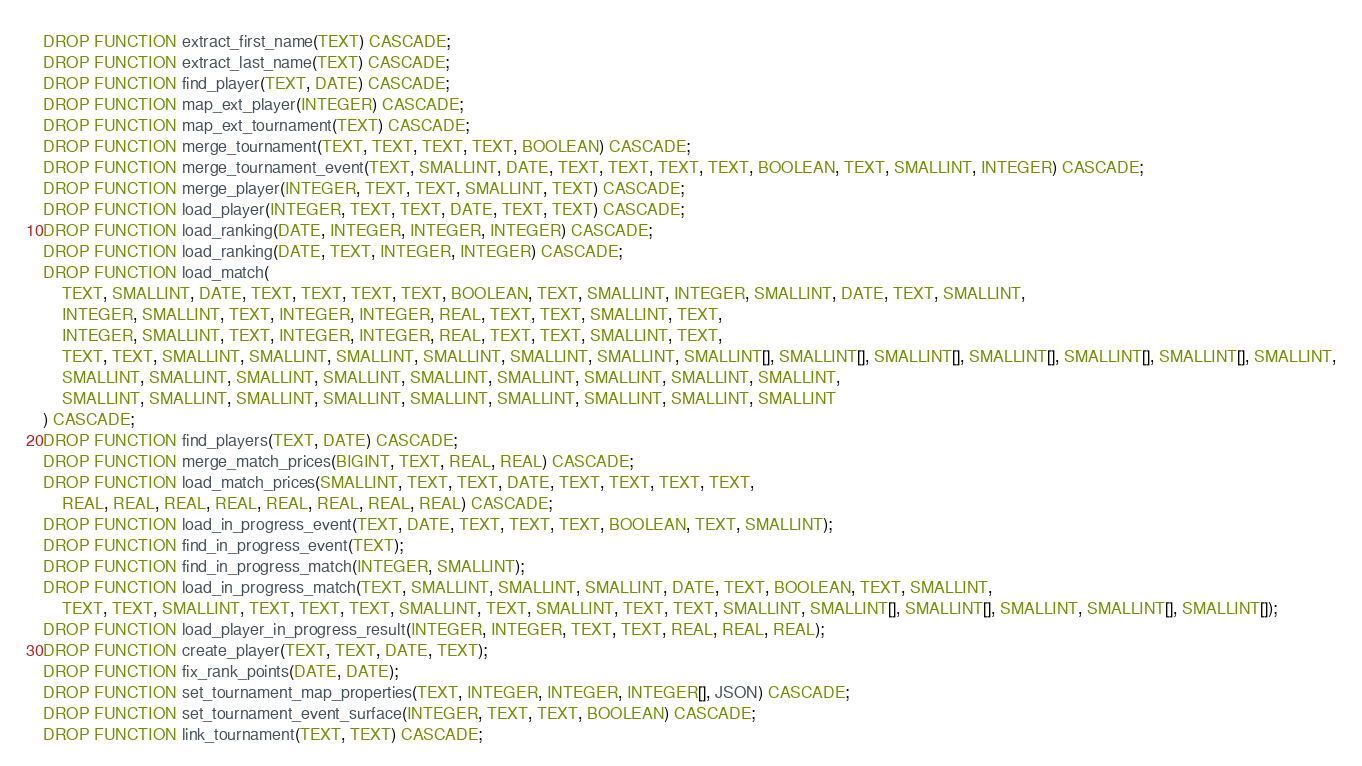<code> <loc_0><loc_0><loc_500><loc_500><_SQL_>DROP FUNCTION extract_first_name(TEXT) CASCADE;
DROP FUNCTION extract_last_name(TEXT) CASCADE;
DROP FUNCTION find_player(TEXT, DATE) CASCADE;
DROP FUNCTION map_ext_player(INTEGER) CASCADE;
DROP FUNCTION map_ext_tournament(TEXT) CASCADE;
DROP FUNCTION merge_tournament(TEXT, TEXT, TEXT, TEXT, BOOLEAN) CASCADE;
DROP FUNCTION merge_tournament_event(TEXT, SMALLINT, DATE, TEXT, TEXT, TEXT, TEXT, BOOLEAN, TEXT, SMALLINT, INTEGER) CASCADE;
DROP FUNCTION merge_player(INTEGER, TEXT, TEXT, SMALLINT, TEXT) CASCADE;
DROP FUNCTION load_player(INTEGER, TEXT, TEXT, DATE, TEXT, TEXT) CASCADE;
DROP FUNCTION load_ranking(DATE, INTEGER, INTEGER, INTEGER) CASCADE;
DROP FUNCTION load_ranking(DATE, TEXT, INTEGER, INTEGER) CASCADE;
DROP FUNCTION load_match(
	TEXT, SMALLINT, DATE, TEXT, TEXT, TEXT, TEXT, BOOLEAN, TEXT, SMALLINT, INTEGER, SMALLINT, DATE, TEXT, SMALLINT,
	INTEGER, SMALLINT, TEXT, INTEGER, INTEGER, REAL, TEXT, TEXT, SMALLINT, TEXT,
	INTEGER, SMALLINT, TEXT, INTEGER, INTEGER, REAL, TEXT, TEXT, SMALLINT, TEXT,
	TEXT, TEXT, SMALLINT, SMALLINT, SMALLINT, SMALLINT, SMALLINT, SMALLINT, SMALLINT[], SMALLINT[], SMALLINT[], SMALLINT[], SMALLINT[], SMALLINT[], SMALLINT,
	SMALLINT, SMALLINT, SMALLINT, SMALLINT, SMALLINT, SMALLINT, SMALLINT, SMALLINT, SMALLINT,
	SMALLINT, SMALLINT, SMALLINT, SMALLINT, SMALLINT, SMALLINT, SMALLINT, SMALLINT, SMALLINT
) CASCADE;
DROP FUNCTION find_players(TEXT, DATE) CASCADE;
DROP FUNCTION merge_match_prices(BIGINT, TEXT, REAL, REAL) CASCADE;
DROP FUNCTION load_match_prices(SMALLINT, TEXT, TEXT, DATE, TEXT, TEXT, TEXT, TEXT,
	REAL, REAL, REAL, REAL, REAL, REAL, REAL, REAL) CASCADE;
DROP FUNCTION load_in_progress_event(TEXT, DATE, TEXT, TEXT, TEXT, BOOLEAN, TEXT, SMALLINT);
DROP FUNCTION find_in_progress_event(TEXT);
DROP FUNCTION find_in_progress_match(INTEGER, SMALLINT);
DROP FUNCTION load_in_progress_match(TEXT, SMALLINT, SMALLINT, SMALLINT, DATE, TEXT, BOOLEAN, TEXT, SMALLINT,
	TEXT, TEXT, SMALLINT, TEXT, TEXT, TEXT, SMALLINT, TEXT, SMALLINT, TEXT, TEXT, SMALLINT, SMALLINT[], SMALLINT[], SMALLINT, SMALLINT[], SMALLINT[]);
DROP FUNCTION load_player_in_progress_result(INTEGER, INTEGER, TEXT, TEXT, REAL, REAL, REAL);
DROP FUNCTION create_player(TEXT, TEXT, DATE, TEXT);
DROP FUNCTION fix_rank_points(DATE, DATE);
DROP FUNCTION set_tournament_map_properties(TEXT, INTEGER, INTEGER, INTEGER[], JSON) CASCADE;
DROP FUNCTION set_tournament_event_surface(INTEGER, TEXT, TEXT, BOOLEAN) CASCADE;
DROP FUNCTION link_tournament(TEXT, TEXT) CASCADE;</code> 